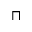Convert formula to latex. <formula><loc_0><loc_0><loc_500><loc_500>\sqcap</formula> 